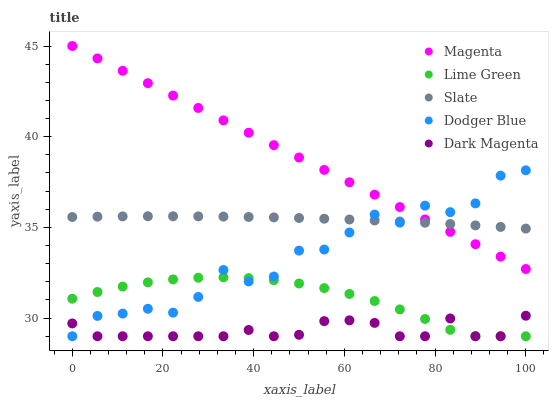Does Dark Magenta have the minimum area under the curve?
Answer yes or no. Yes. Does Magenta have the maximum area under the curve?
Answer yes or no. Yes. Does Lime Green have the minimum area under the curve?
Answer yes or no. No. Does Lime Green have the maximum area under the curve?
Answer yes or no. No. Is Magenta the smoothest?
Answer yes or no. Yes. Is Dodger Blue the roughest?
Answer yes or no. Yes. Is Lime Green the smoothest?
Answer yes or no. No. Is Lime Green the roughest?
Answer yes or no. No. Does Dodger Blue have the lowest value?
Answer yes or no. Yes. Does Magenta have the lowest value?
Answer yes or no. No. Does Magenta have the highest value?
Answer yes or no. Yes. Does Lime Green have the highest value?
Answer yes or no. No. Is Dark Magenta less than Slate?
Answer yes or no. Yes. Is Slate greater than Lime Green?
Answer yes or no. Yes. Does Dodger Blue intersect Slate?
Answer yes or no. Yes. Is Dodger Blue less than Slate?
Answer yes or no. No. Is Dodger Blue greater than Slate?
Answer yes or no. No. Does Dark Magenta intersect Slate?
Answer yes or no. No. 